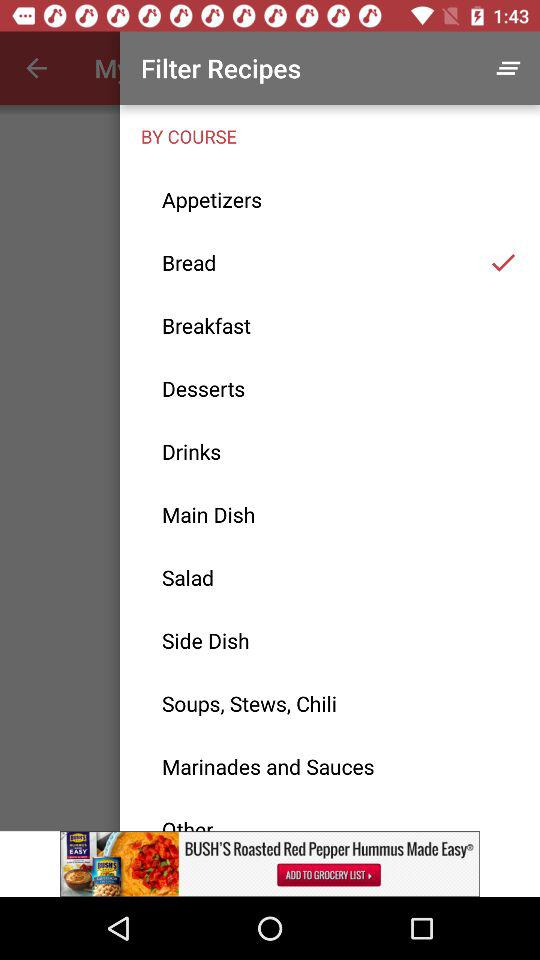Which item is selected? The selected item is "Bread". 